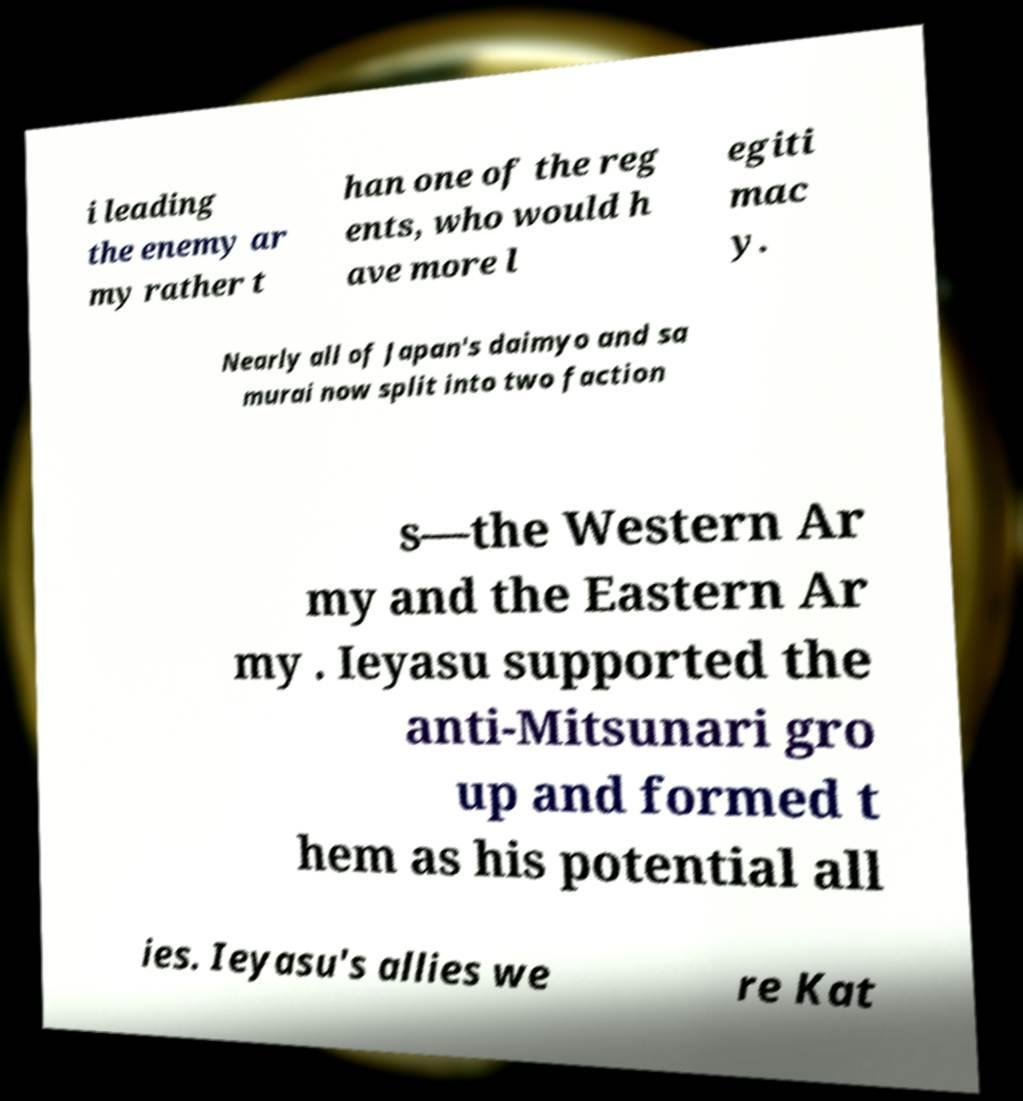For documentation purposes, I need the text within this image transcribed. Could you provide that? i leading the enemy ar my rather t han one of the reg ents, who would h ave more l egiti mac y. Nearly all of Japan's daimyo and sa murai now split into two faction s—the Western Ar my and the Eastern Ar my . Ieyasu supported the anti-Mitsunari gro up and formed t hem as his potential all ies. Ieyasu's allies we re Kat 